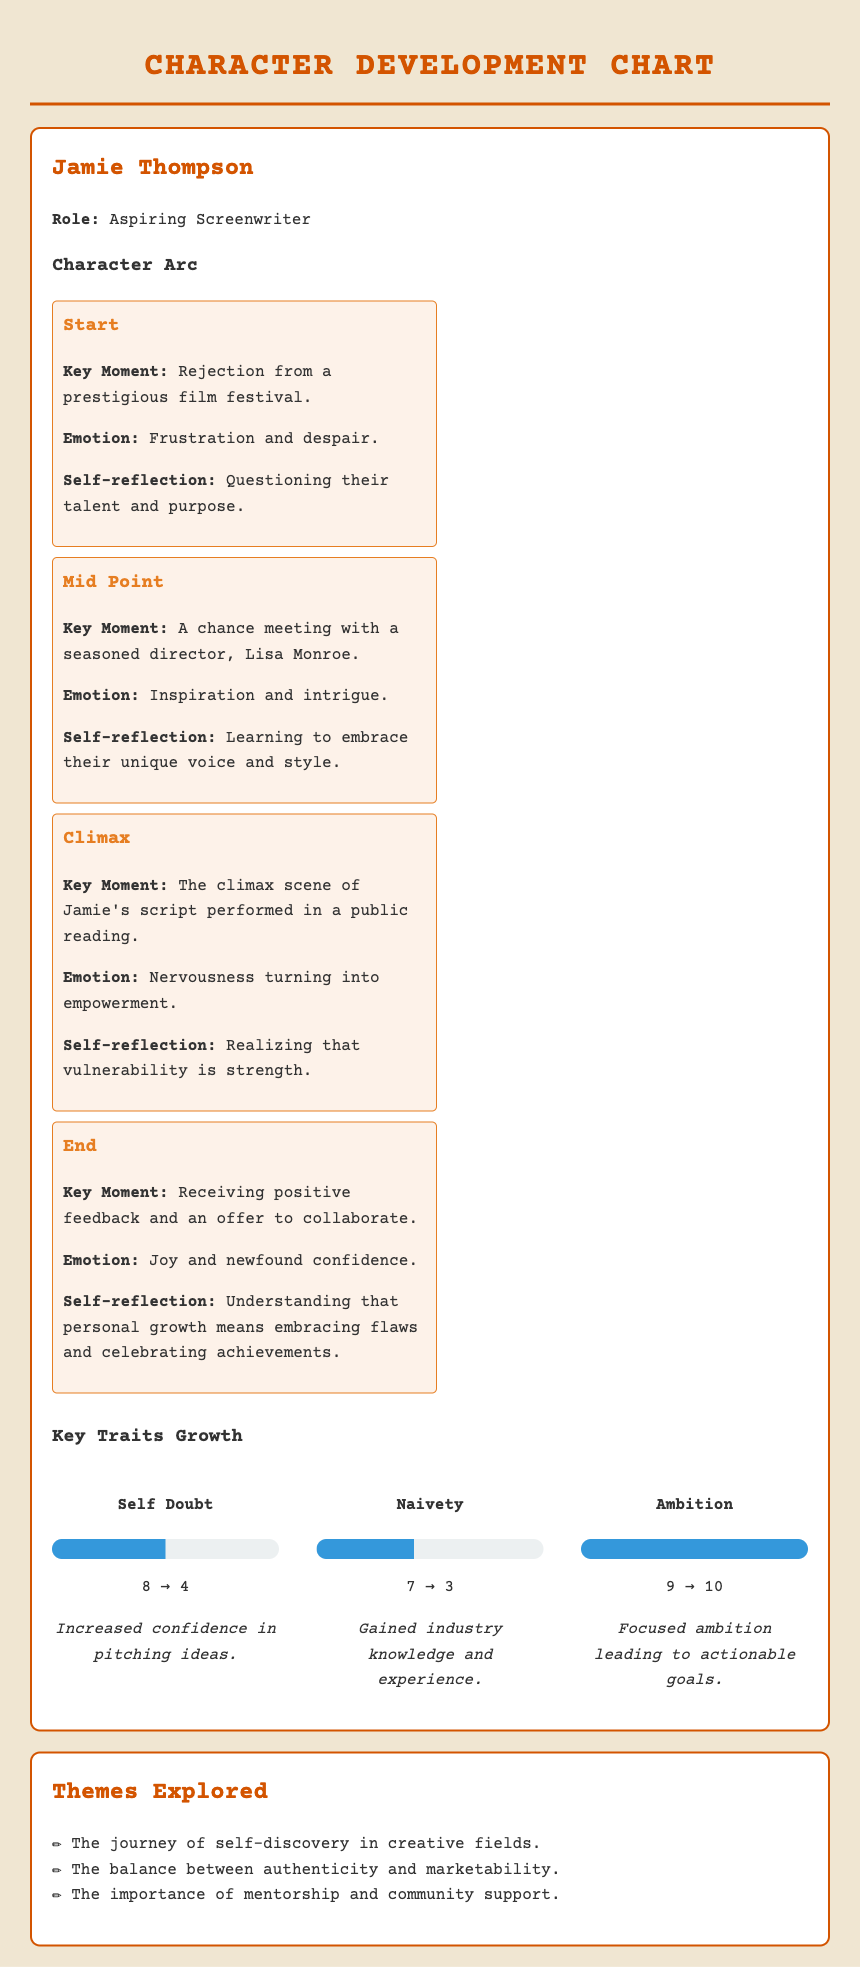What is the protagonist's name? The document explicitly names the protagonist at the top of the character info section as Jamie Thompson.
Answer: Jamie Thompson What key moment signifies the protagonist's start? The document describes the protagonist's starting arc, which includes their rejection from a prestigious film festival as the key moment.
Answer: Rejection from a prestigious film festival What emotion does Jamie experience at the climax? The document specifies that Jamie feels nervousness turning into empowerment during the climax scene of their script performed in a public reading.
Answer: Nervousness turning into empowerment How much did Jamie's self-doubt score change? The document provides the self-doubt scores before and after, indicating it decreased from 8 to 4, making the total change 4.
Answer: 4 What is one theme explored in the story? The document lists several themes, and one of them is the journey of self-discovery in creative fields.
Answer: The journey of self-discovery in creative fields What is the protagonist's role? The document clearly states Jamie Thompson's role as an aspiring screenwriter within the character info section.
Answer: Aspiring Screenwriter How did Jamie's ambition score evolve? According to the document, Jamie's ambition increased from a score of 9 to 10, demonstrating growth in this trait.
Answer: 10 What is the primary emotion expressed at the end? The document outlines the final emotion Jamie experiences, which is joy and newfound confidence after receiving positive feedback.
Answer: Joy and newfound confidence 